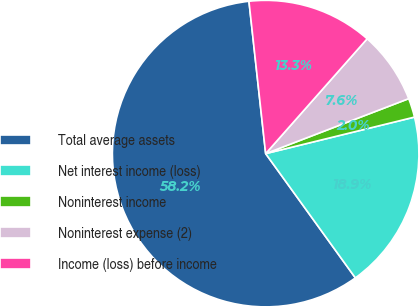Convert chart. <chart><loc_0><loc_0><loc_500><loc_500><pie_chart><fcel>Total average assets<fcel>Net interest income (loss)<fcel>Noninterest income<fcel>Noninterest expense (2)<fcel>Income (loss) before income<nl><fcel>58.22%<fcel>18.88%<fcel>2.01%<fcel>7.64%<fcel>13.26%<nl></chart> 